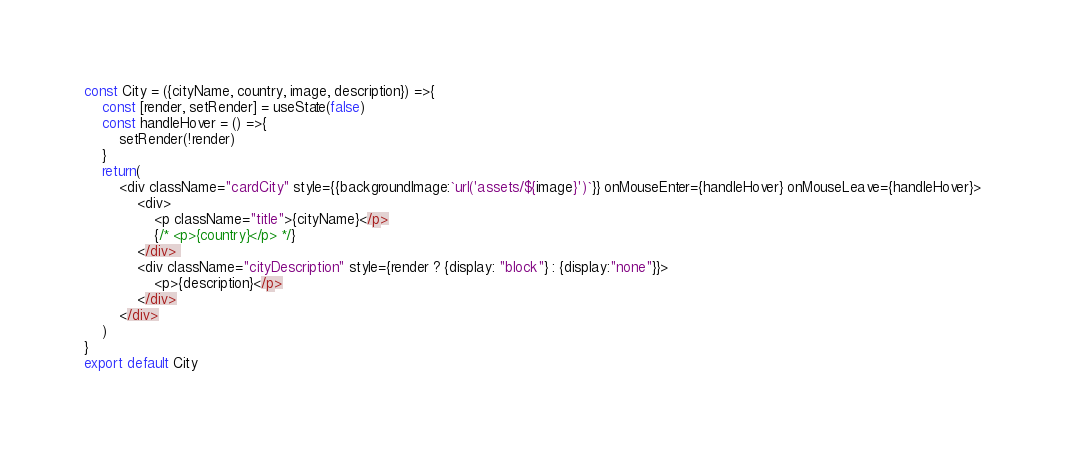<code> <loc_0><loc_0><loc_500><loc_500><_JavaScript_>
const City = ({cityName, country, image, description}) =>{
    const [render, setRender] = useState(false)
    const handleHover = () =>{
        setRender(!render)
    }
    return(
        <div className="cardCity" style={{backgroundImage:`url('assets/${image}')`}} onMouseEnter={handleHover} onMouseLeave={handleHover}>
            <div>   
                <p className="title">{cityName}</p>
                {/* <p>{country}</p> */}
            </div> 
            <div className="cityDescription" style={render ? {display: "block"} : {display:"none"}}>
                <p>{description}</p>
            </div>
        </div>
    )
}
export default City</code> 